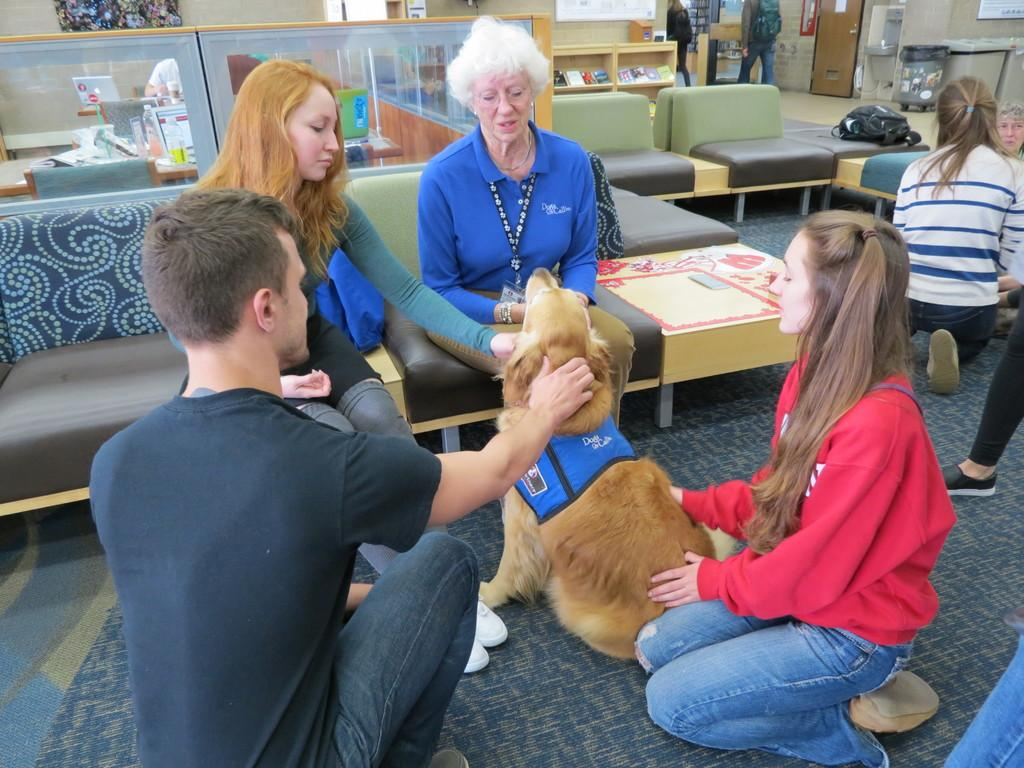What is the main activity of the people in the image? There are many people sitting in the image. What type of animal can be seen in the image? There is a dog in the image. What type of furniture is present in the image? There are sofa chairs in the image. What time is the dog making a request in the image? There is no indication of time in the image, and the dog is not making any requests. 